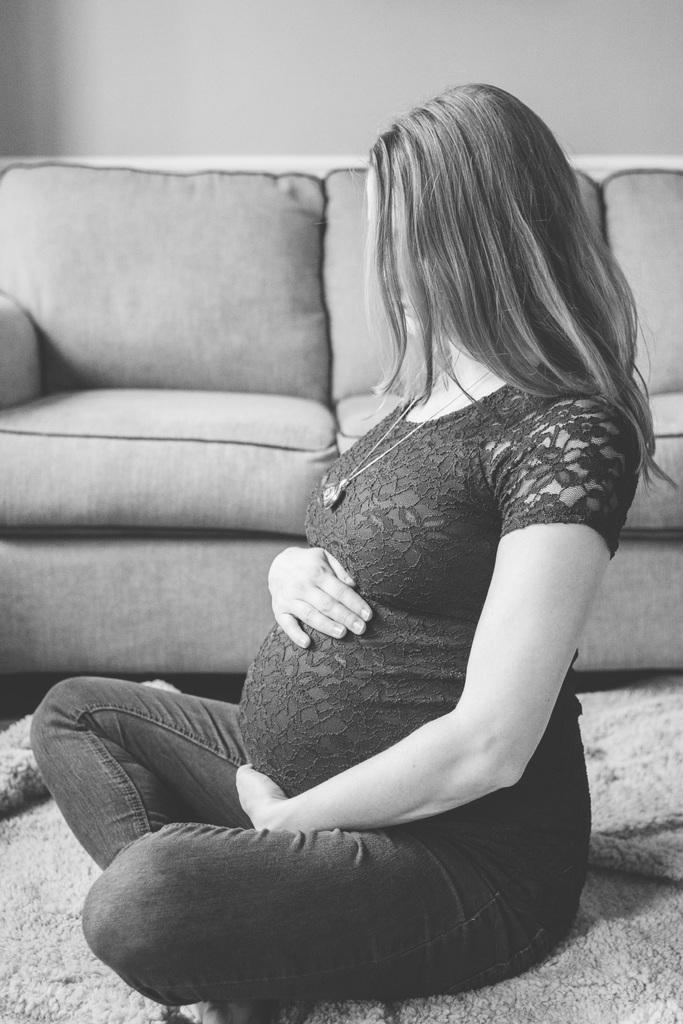Could you give a brief overview of what you see in this image? A woman is sitting on the floor and she is pregnant. Behind her there is a sofa and wall. 